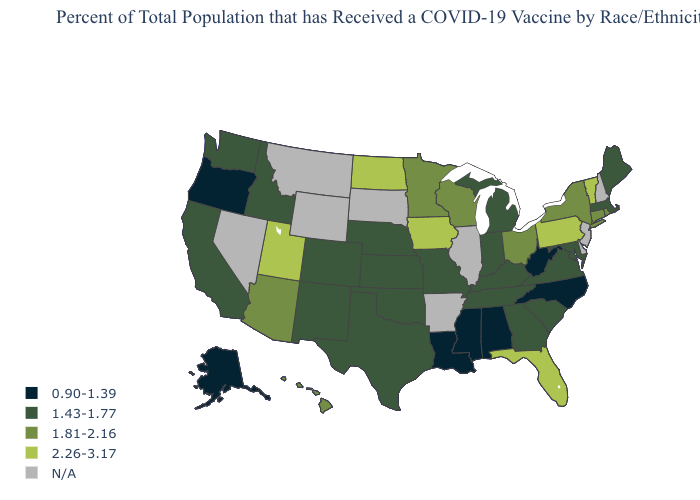Name the states that have a value in the range 2.26-3.17?
Short answer required. Florida, Iowa, North Dakota, Pennsylvania, Utah, Vermont. What is the value of Georgia?
Short answer required. 1.43-1.77. Name the states that have a value in the range N/A?
Keep it brief. Arkansas, Delaware, Illinois, Montana, Nevada, New Hampshire, New Jersey, South Dakota, Wyoming. Is the legend a continuous bar?
Give a very brief answer. No. Name the states that have a value in the range 0.90-1.39?
Be succinct. Alabama, Alaska, Louisiana, Mississippi, North Carolina, Oregon, West Virginia. Among the states that border Utah , does Colorado have the lowest value?
Keep it brief. Yes. Which states have the lowest value in the USA?
Answer briefly. Alabama, Alaska, Louisiana, Mississippi, North Carolina, Oregon, West Virginia. Name the states that have a value in the range N/A?
Concise answer only. Arkansas, Delaware, Illinois, Montana, Nevada, New Hampshire, New Jersey, South Dakota, Wyoming. What is the value of Montana?
Give a very brief answer. N/A. What is the value of California?
Concise answer only. 1.43-1.77. Which states have the lowest value in the MidWest?
Give a very brief answer. Indiana, Kansas, Michigan, Missouri, Nebraska. What is the value of Florida?
Be succinct. 2.26-3.17. Name the states that have a value in the range 0.90-1.39?
Answer briefly. Alabama, Alaska, Louisiana, Mississippi, North Carolina, Oregon, West Virginia. Does the first symbol in the legend represent the smallest category?
Concise answer only. Yes. What is the lowest value in the West?
Concise answer only. 0.90-1.39. 